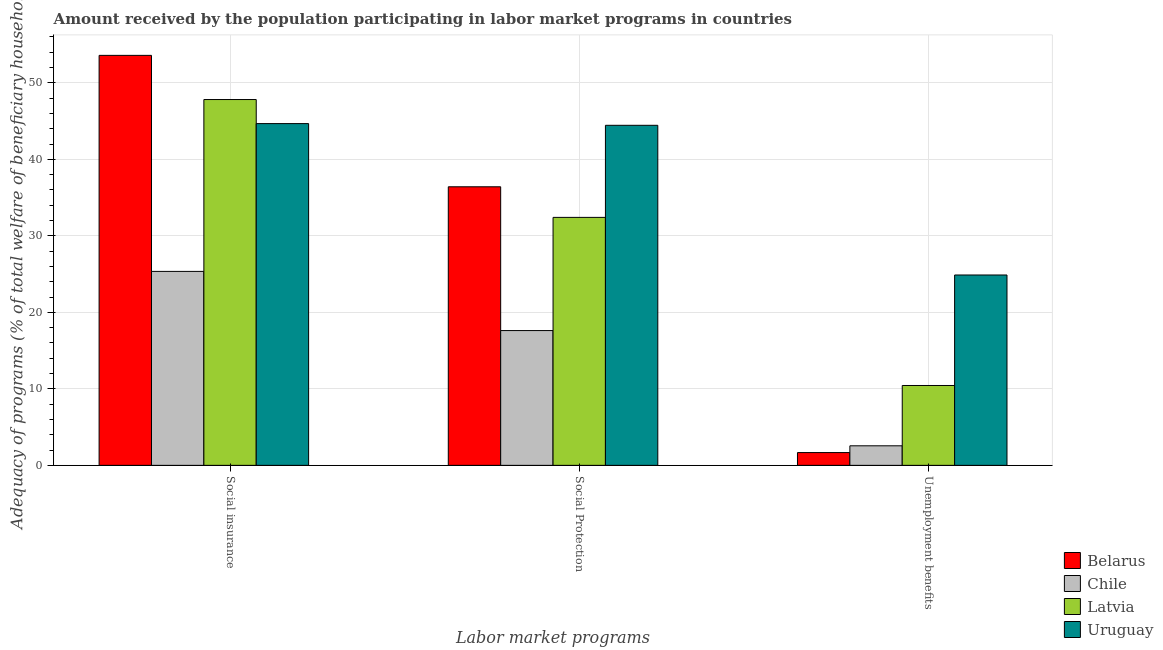How many different coloured bars are there?
Provide a short and direct response. 4. Are the number of bars on each tick of the X-axis equal?
Your answer should be compact. Yes. How many bars are there on the 1st tick from the right?
Your answer should be compact. 4. What is the label of the 1st group of bars from the left?
Give a very brief answer. Social insurance. What is the amount received by the population participating in social protection programs in Belarus?
Provide a short and direct response. 36.42. Across all countries, what is the maximum amount received by the population participating in unemployment benefits programs?
Give a very brief answer. 24.89. Across all countries, what is the minimum amount received by the population participating in unemployment benefits programs?
Offer a terse response. 1.67. In which country was the amount received by the population participating in unemployment benefits programs maximum?
Your answer should be compact. Uruguay. What is the total amount received by the population participating in social insurance programs in the graph?
Your answer should be compact. 171.45. What is the difference between the amount received by the population participating in social protection programs in Belarus and that in Chile?
Your answer should be very brief. 18.8. What is the difference between the amount received by the population participating in unemployment benefits programs in Chile and the amount received by the population participating in social insurance programs in Uruguay?
Offer a terse response. -42.12. What is the average amount received by the population participating in unemployment benefits programs per country?
Provide a short and direct response. 9.89. What is the difference between the amount received by the population participating in social protection programs and amount received by the population participating in unemployment benefits programs in Chile?
Make the answer very short. 15.07. What is the ratio of the amount received by the population participating in social protection programs in Uruguay to that in Chile?
Your answer should be compact. 2.52. Is the amount received by the population participating in unemployment benefits programs in Chile less than that in Belarus?
Your response must be concise. No. What is the difference between the highest and the second highest amount received by the population participating in social insurance programs?
Provide a succinct answer. 5.77. What is the difference between the highest and the lowest amount received by the population participating in social insurance programs?
Give a very brief answer. 28.24. Is the sum of the amount received by the population participating in unemployment benefits programs in Uruguay and Latvia greater than the maximum amount received by the population participating in social protection programs across all countries?
Your answer should be compact. No. What does the 1st bar from the right in Unemployment benefits represents?
Keep it short and to the point. Uruguay. Is it the case that in every country, the sum of the amount received by the population participating in social insurance programs and amount received by the population participating in social protection programs is greater than the amount received by the population participating in unemployment benefits programs?
Your answer should be compact. Yes. Are all the bars in the graph horizontal?
Keep it short and to the point. No. How many countries are there in the graph?
Give a very brief answer. 4. What is the difference between two consecutive major ticks on the Y-axis?
Your answer should be compact. 10. Are the values on the major ticks of Y-axis written in scientific E-notation?
Make the answer very short. No. Does the graph contain grids?
Give a very brief answer. Yes. How are the legend labels stacked?
Give a very brief answer. Vertical. What is the title of the graph?
Provide a succinct answer. Amount received by the population participating in labor market programs in countries. What is the label or title of the X-axis?
Provide a succinct answer. Labor market programs. What is the label or title of the Y-axis?
Your answer should be compact. Adequacy of programs (% of total welfare of beneficiary households). What is the Adequacy of programs (% of total welfare of beneficiary households) of Belarus in Social insurance?
Provide a succinct answer. 53.6. What is the Adequacy of programs (% of total welfare of beneficiary households) in Chile in Social insurance?
Your answer should be very brief. 25.36. What is the Adequacy of programs (% of total welfare of beneficiary households) of Latvia in Social insurance?
Provide a short and direct response. 47.82. What is the Adequacy of programs (% of total welfare of beneficiary households) of Uruguay in Social insurance?
Provide a short and direct response. 44.68. What is the Adequacy of programs (% of total welfare of beneficiary households) in Belarus in Social Protection?
Give a very brief answer. 36.42. What is the Adequacy of programs (% of total welfare of beneficiary households) of Chile in Social Protection?
Your answer should be very brief. 17.62. What is the Adequacy of programs (% of total welfare of beneficiary households) of Latvia in Social Protection?
Keep it short and to the point. 32.42. What is the Adequacy of programs (% of total welfare of beneficiary households) of Uruguay in Social Protection?
Your answer should be compact. 44.45. What is the Adequacy of programs (% of total welfare of beneficiary households) in Belarus in Unemployment benefits?
Ensure brevity in your answer.  1.67. What is the Adequacy of programs (% of total welfare of beneficiary households) of Chile in Unemployment benefits?
Offer a terse response. 2.55. What is the Adequacy of programs (% of total welfare of beneficiary households) of Latvia in Unemployment benefits?
Offer a terse response. 10.44. What is the Adequacy of programs (% of total welfare of beneficiary households) in Uruguay in Unemployment benefits?
Provide a succinct answer. 24.89. Across all Labor market programs, what is the maximum Adequacy of programs (% of total welfare of beneficiary households) of Belarus?
Provide a succinct answer. 53.6. Across all Labor market programs, what is the maximum Adequacy of programs (% of total welfare of beneficiary households) of Chile?
Ensure brevity in your answer.  25.36. Across all Labor market programs, what is the maximum Adequacy of programs (% of total welfare of beneficiary households) of Latvia?
Give a very brief answer. 47.82. Across all Labor market programs, what is the maximum Adequacy of programs (% of total welfare of beneficiary households) in Uruguay?
Give a very brief answer. 44.68. Across all Labor market programs, what is the minimum Adequacy of programs (% of total welfare of beneficiary households) of Belarus?
Your response must be concise. 1.67. Across all Labor market programs, what is the minimum Adequacy of programs (% of total welfare of beneficiary households) of Chile?
Provide a short and direct response. 2.55. Across all Labor market programs, what is the minimum Adequacy of programs (% of total welfare of beneficiary households) in Latvia?
Your answer should be compact. 10.44. Across all Labor market programs, what is the minimum Adequacy of programs (% of total welfare of beneficiary households) of Uruguay?
Make the answer very short. 24.89. What is the total Adequacy of programs (% of total welfare of beneficiary households) of Belarus in the graph?
Provide a short and direct response. 91.68. What is the total Adequacy of programs (% of total welfare of beneficiary households) in Chile in the graph?
Offer a terse response. 45.53. What is the total Adequacy of programs (% of total welfare of beneficiary households) of Latvia in the graph?
Make the answer very short. 90.68. What is the total Adequacy of programs (% of total welfare of beneficiary households) in Uruguay in the graph?
Give a very brief answer. 114.02. What is the difference between the Adequacy of programs (% of total welfare of beneficiary households) of Belarus in Social insurance and that in Social Protection?
Your answer should be compact. 17.18. What is the difference between the Adequacy of programs (% of total welfare of beneficiary households) of Chile in Social insurance and that in Social Protection?
Ensure brevity in your answer.  7.73. What is the difference between the Adequacy of programs (% of total welfare of beneficiary households) of Latvia in Social insurance and that in Social Protection?
Keep it short and to the point. 15.41. What is the difference between the Adequacy of programs (% of total welfare of beneficiary households) of Uruguay in Social insurance and that in Social Protection?
Give a very brief answer. 0.22. What is the difference between the Adequacy of programs (% of total welfare of beneficiary households) of Belarus in Social insurance and that in Unemployment benefits?
Give a very brief answer. 51.93. What is the difference between the Adequacy of programs (% of total welfare of beneficiary households) in Chile in Social insurance and that in Unemployment benefits?
Offer a terse response. 22.8. What is the difference between the Adequacy of programs (% of total welfare of beneficiary households) in Latvia in Social insurance and that in Unemployment benefits?
Your response must be concise. 37.38. What is the difference between the Adequacy of programs (% of total welfare of beneficiary households) of Uruguay in Social insurance and that in Unemployment benefits?
Your response must be concise. 19.79. What is the difference between the Adequacy of programs (% of total welfare of beneficiary households) of Belarus in Social Protection and that in Unemployment benefits?
Keep it short and to the point. 34.75. What is the difference between the Adequacy of programs (% of total welfare of beneficiary households) in Chile in Social Protection and that in Unemployment benefits?
Provide a short and direct response. 15.07. What is the difference between the Adequacy of programs (% of total welfare of beneficiary households) of Latvia in Social Protection and that in Unemployment benefits?
Offer a terse response. 21.98. What is the difference between the Adequacy of programs (% of total welfare of beneficiary households) in Uruguay in Social Protection and that in Unemployment benefits?
Provide a short and direct response. 19.57. What is the difference between the Adequacy of programs (% of total welfare of beneficiary households) in Belarus in Social insurance and the Adequacy of programs (% of total welfare of beneficiary households) in Chile in Social Protection?
Provide a short and direct response. 35.98. What is the difference between the Adequacy of programs (% of total welfare of beneficiary households) of Belarus in Social insurance and the Adequacy of programs (% of total welfare of beneficiary households) of Latvia in Social Protection?
Your response must be concise. 21.18. What is the difference between the Adequacy of programs (% of total welfare of beneficiary households) in Belarus in Social insurance and the Adequacy of programs (% of total welfare of beneficiary households) in Uruguay in Social Protection?
Ensure brevity in your answer.  9.14. What is the difference between the Adequacy of programs (% of total welfare of beneficiary households) of Chile in Social insurance and the Adequacy of programs (% of total welfare of beneficiary households) of Latvia in Social Protection?
Offer a terse response. -7.06. What is the difference between the Adequacy of programs (% of total welfare of beneficiary households) of Chile in Social insurance and the Adequacy of programs (% of total welfare of beneficiary households) of Uruguay in Social Protection?
Your response must be concise. -19.1. What is the difference between the Adequacy of programs (% of total welfare of beneficiary households) in Latvia in Social insurance and the Adequacy of programs (% of total welfare of beneficiary households) in Uruguay in Social Protection?
Make the answer very short. 3.37. What is the difference between the Adequacy of programs (% of total welfare of beneficiary households) of Belarus in Social insurance and the Adequacy of programs (% of total welfare of beneficiary households) of Chile in Unemployment benefits?
Provide a succinct answer. 51.04. What is the difference between the Adequacy of programs (% of total welfare of beneficiary households) of Belarus in Social insurance and the Adequacy of programs (% of total welfare of beneficiary households) of Latvia in Unemployment benefits?
Your answer should be compact. 43.16. What is the difference between the Adequacy of programs (% of total welfare of beneficiary households) in Belarus in Social insurance and the Adequacy of programs (% of total welfare of beneficiary households) in Uruguay in Unemployment benefits?
Give a very brief answer. 28.71. What is the difference between the Adequacy of programs (% of total welfare of beneficiary households) of Chile in Social insurance and the Adequacy of programs (% of total welfare of beneficiary households) of Latvia in Unemployment benefits?
Your answer should be compact. 14.91. What is the difference between the Adequacy of programs (% of total welfare of beneficiary households) of Chile in Social insurance and the Adequacy of programs (% of total welfare of beneficiary households) of Uruguay in Unemployment benefits?
Your response must be concise. 0.47. What is the difference between the Adequacy of programs (% of total welfare of beneficiary households) in Latvia in Social insurance and the Adequacy of programs (% of total welfare of beneficiary households) in Uruguay in Unemployment benefits?
Your answer should be compact. 22.94. What is the difference between the Adequacy of programs (% of total welfare of beneficiary households) in Belarus in Social Protection and the Adequacy of programs (% of total welfare of beneficiary households) in Chile in Unemployment benefits?
Your answer should be very brief. 33.86. What is the difference between the Adequacy of programs (% of total welfare of beneficiary households) of Belarus in Social Protection and the Adequacy of programs (% of total welfare of beneficiary households) of Latvia in Unemployment benefits?
Keep it short and to the point. 25.98. What is the difference between the Adequacy of programs (% of total welfare of beneficiary households) of Belarus in Social Protection and the Adequacy of programs (% of total welfare of beneficiary households) of Uruguay in Unemployment benefits?
Offer a terse response. 11.53. What is the difference between the Adequacy of programs (% of total welfare of beneficiary households) of Chile in Social Protection and the Adequacy of programs (% of total welfare of beneficiary households) of Latvia in Unemployment benefits?
Offer a very short reply. 7.18. What is the difference between the Adequacy of programs (% of total welfare of beneficiary households) of Chile in Social Protection and the Adequacy of programs (% of total welfare of beneficiary households) of Uruguay in Unemployment benefits?
Give a very brief answer. -7.27. What is the difference between the Adequacy of programs (% of total welfare of beneficiary households) in Latvia in Social Protection and the Adequacy of programs (% of total welfare of beneficiary households) in Uruguay in Unemployment benefits?
Provide a short and direct response. 7.53. What is the average Adequacy of programs (% of total welfare of beneficiary households) of Belarus per Labor market programs?
Give a very brief answer. 30.56. What is the average Adequacy of programs (% of total welfare of beneficiary households) of Chile per Labor market programs?
Provide a succinct answer. 15.18. What is the average Adequacy of programs (% of total welfare of beneficiary households) of Latvia per Labor market programs?
Provide a short and direct response. 30.23. What is the average Adequacy of programs (% of total welfare of beneficiary households) of Uruguay per Labor market programs?
Your answer should be compact. 38.01. What is the difference between the Adequacy of programs (% of total welfare of beneficiary households) in Belarus and Adequacy of programs (% of total welfare of beneficiary households) in Chile in Social insurance?
Offer a terse response. 28.24. What is the difference between the Adequacy of programs (% of total welfare of beneficiary households) of Belarus and Adequacy of programs (% of total welfare of beneficiary households) of Latvia in Social insurance?
Make the answer very short. 5.77. What is the difference between the Adequacy of programs (% of total welfare of beneficiary households) in Belarus and Adequacy of programs (% of total welfare of beneficiary households) in Uruguay in Social insurance?
Your answer should be compact. 8.92. What is the difference between the Adequacy of programs (% of total welfare of beneficiary households) of Chile and Adequacy of programs (% of total welfare of beneficiary households) of Latvia in Social insurance?
Your answer should be very brief. -22.47. What is the difference between the Adequacy of programs (% of total welfare of beneficiary households) in Chile and Adequacy of programs (% of total welfare of beneficiary households) in Uruguay in Social insurance?
Ensure brevity in your answer.  -19.32. What is the difference between the Adequacy of programs (% of total welfare of beneficiary households) in Latvia and Adequacy of programs (% of total welfare of beneficiary households) in Uruguay in Social insurance?
Offer a terse response. 3.15. What is the difference between the Adequacy of programs (% of total welfare of beneficiary households) in Belarus and Adequacy of programs (% of total welfare of beneficiary households) in Chile in Social Protection?
Offer a very short reply. 18.8. What is the difference between the Adequacy of programs (% of total welfare of beneficiary households) in Belarus and Adequacy of programs (% of total welfare of beneficiary households) in Latvia in Social Protection?
Give a very brief answer. 4. What is the difference between the Adequacy of programs (% of total welfare of beneficiary households) in Belarus and Adequacy of programs (% of total welfare of beneficiary households) in Uruguay in Social Protection?
Your response must be concise. -8.04. What is the difference between the Adequacy of programs (% of total welfare of beneficiary households) of Chile and Adequacy of programs (% of total welfare of beneficiary households) of Latvia in Social Protection?
Make the answer very short. -14.8. What is the difference between the Adequacy of programs (% of total welfare of beneficiary households) of Chile and Adequacy of programs (% of total welfare of beneficiary households) of Uruguay in Social Protection?
Provide a succinct answer. -26.83. What is the difference between the Adequacy of programs (% of total welfare of beneficiary households) in Latvia and Adequacy of programs (% of total welfare of beneficiary households) in Uruguay in Social Protection?
Your answer should be very brief. -12.04. What is the difference between the Adequacy of programs (% of total welfare of beneficiary households) of Belarus and Adequacy of programs (% of total welfare of beneficiary households) of Chile in Unemployment benefits?
Keep it short and to the point. -0.88. What is the difference between the Adequacy of programs (% of total welfare of beneficiary households) in Belarus and Adequacy of programs (% of total welfare of beneficiary households) in Latvia in Unemployment benefits?
Ensure brevity in your answer.  -8.77. What is the difference between the Adequacy of programs (% of total welfare of beneficiary households) of Belarus and Adequacy of programs (% of total welfare of beneficiary households) of Uruguay in Unemployment benefits?
Your answer should be compact. -23.22. What is the difference between the Adequacy of programs (% of total welfare of beneficiary households) of Chile and Adequacy of programs (% of total welfare of beneficiary households) of Latvia in Unemployment benefits?
Your answer should be compact. -7.89. What is the difference between the Adequacy of programs (% of total welfare of beneficiary households) of Chile and Adequacy of programs (% of total welfare of beneficiary households) of Uruguay in Unemployment benefits?
Your response must be concise. -22.33. What is the difference between the Adequacy of programs (% of total welfare of beneficiary households) in Latvia and Adequacy of programs (% of total welfare of beneficiary households) in Uruguay in Unemployment benefits?
Give a very brief answer. -14.45. What is the ratio of the Adequacy of programs (% of total welfare of beneficiary households) in Belarus in Social insurance to that in Social Protection?
Your answer should be very brief. 1.47. What is the ratio of the Adequacy of programs (% of total welfare of beneficiary households) in Chile in Social insurance to that in Social Protection?
Your answer should be compact. 1.44. What is the ratio of the Adequacy of programs (% of total welfare of beneficiary households) in Latvia in Social insurance to that in Social Protection?
Offer a terse response. 1.48. What is the ratio of the Adequacy of programs (% of total welfare of beneficiary households) in Uruguay in Social insurance to that in Social Protection?
Make the answer very short. 1. What is the ratio of the Adequacy of programs (% of total welfare of beneficiary households) in Belarus in Social insurance to that in Unemployment benefits?
Your answer should be very brief. 32.09. What is the ratio of the Adequacy of programs (% of total welfare of beneficiary households) of Chile in Social insurance to that in Unemployment benefits?
Your answer should be compact. 9.92. What is the ratio of the Adequacy of programs (% of total welfare of beneficiary households) of Latvia in Social insurance to that in Unemployment benefits?
Your response must be concise. 4.58. What is the ratio of the Adequacy of programs (% of total welfare of beneficiary households) in Uruguay in Social insurance to that in Unemployment benefits?
Your response must be concise. 1.8. What is the ratio of the Adequacy of programs (% of total welfare of beneficiary households) in Belarus in Social Protection to that in Unemployment benefits?
Your answer should be compact. 21.8. What is the ratio of the Adequacy of programs (% of total welfare of beneficiary households) in Chile in Social Protection to that in Unemployment benefits?
Keep it short and to the point. 6.9. What is the ratio of the Adequacy of programs (% of total welfare of beneficiary households) of Latvia in Social Protection to that in Unemployment benefits?
Make the answer very short. 3.1. What is the ratio of the Adequacy of programs (% of total welfare of beneficiary households) of Uruguay in Social Protection to that in Unemployment benefits?
Keep it short and to the point. 1.79. What is the difference between the highest and the second highest Adequacy of programs (% of total welfare of beneficiary households) of Belarus?
Provide a short and direct response. 17.18. What is the difference between the highest and the second highest Adequacy of programs (% of total welfare of beneficiary households) in Chile?
Your answer should be compact. 7.73. What is the difference between the highest and the second highest Adequacy of programs (% of total welfare of beneficiary households) in Latvia?
Your answer should be compact. 15.41. What is the difference between the highest and the second highest Adequacy of programs (% of total welfare of beneficiary households) of Uruguay?
Keep it short and to the point. 0.22. What is the difference between the highest and the lowest Adequacy of programs (% of total welfare of beneficiary households) of Belarus?
Give a very brief answer. 51.93. What is the difference between the highest and the lowest Adequacy of programs (% of total welfare of beneficiary households) in Chile?
Make the answer very short. 22.8. What is the difference between the highest and the lowest Adequacy of programs (% of total welfare of beneficiary households) of Latvia?
Offer a terse response. 37.38. What is the difference between the highest and the lowest Adequacy of programs (% of total welfare of beneficiary households) of Uruguay?
Offer a very short reply. 19.79. 